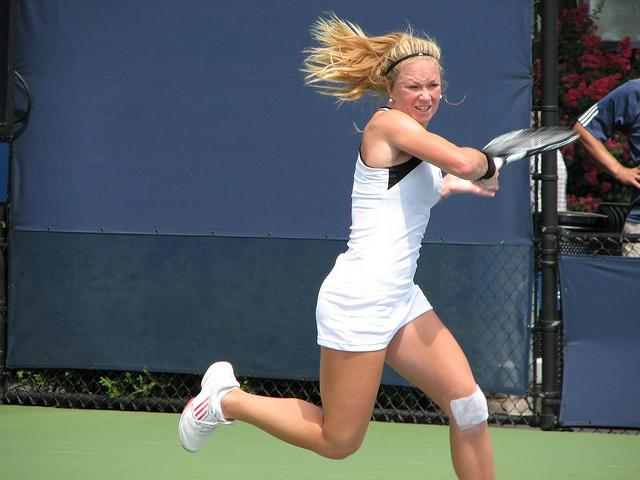What happened to this players left knee? injured 